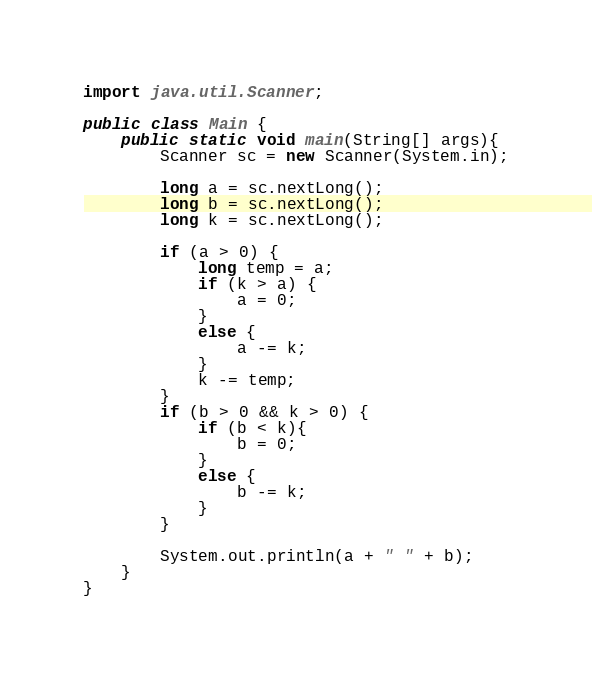<code> <loc_0><loc_0><loc_500><loc_500><_Java_>import java.util.Scanner;

public class Main {
	public static void main(String[] args){
		Scanner sc = new Scanner(System.in);
		
		long a = sc.nextLong();
		long b = sc.nextLong();
		long k = sc.nextLong();

		if (a > 0) {
			long temp = a;
			if (k > a) {
				a = 0;
			}
			else {
				a -= k;
			}
			k -= temp;
		}
		if (b > 0 && k > 0) {
			if (b < k){ 
				b = 0;
			}			
			else {
				b -= k;
			}
		}

		System.out.println(a + " " + b);
	}
}</code> 